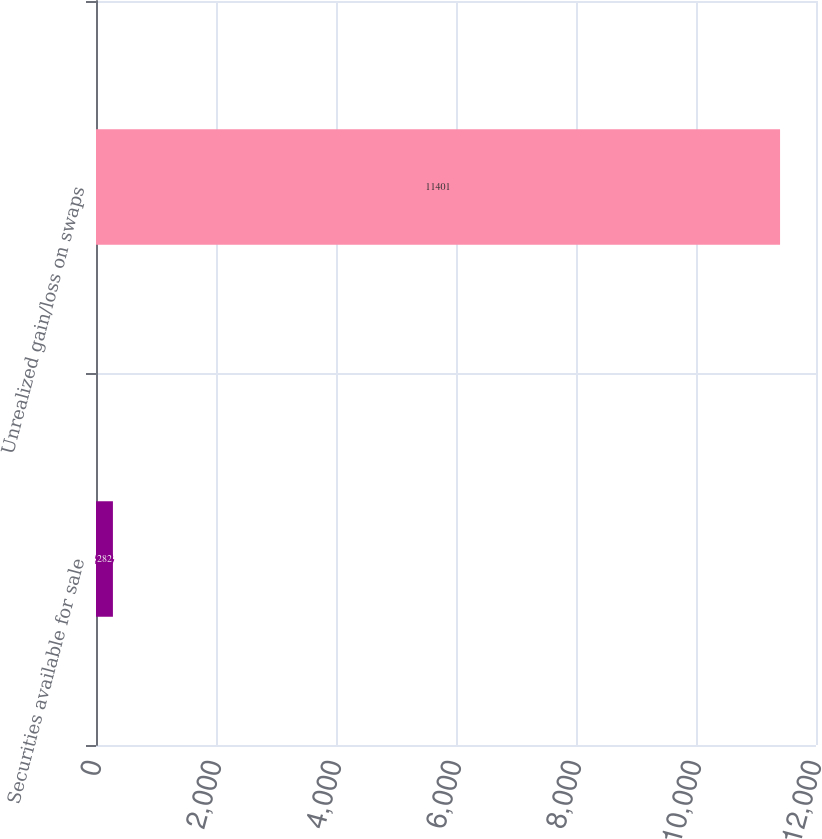Convert chart. <chart><loc_0><loc_0><loc_500><loc_500><bar_chart><fcel>Securities available for sale<fcel>Unrealized gain/loss on swaps<nl><fcel>282<fcel>11401<nl></chart> 